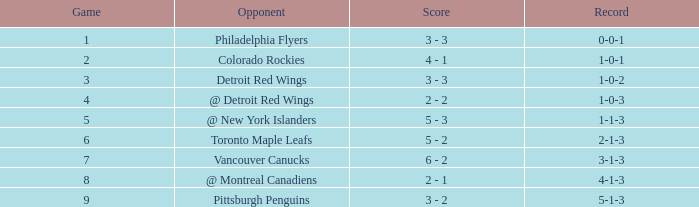Identify the smallest game with a record of 1-0-2 3.0. 